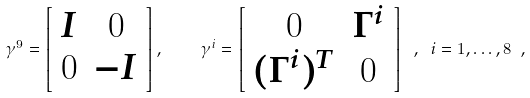Convert formula to latex. <formula><loc_0><loc_0><loc_500><loc_500>\gamma ^ { 9 } = \left [ \begin{array} { c c } I & 0 \\ 0 & - I \end{array} \right ] , \quad \gamma ^ { i } = \left [ \begin{array} { c c } 0 & \Gamma ^ { i } \\ ( \Gamma ^ { i } ) ^ { T } & 0 \end{array} \right ] \ , \ i = 1 , \dots , 8 \ ,</formula> 